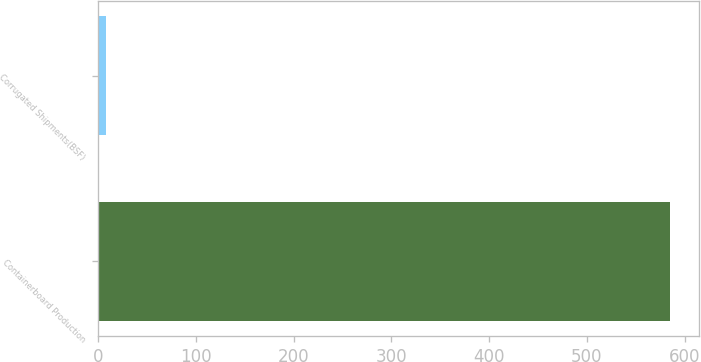<chart> <loc_0><loc_0><loc_500><loc_500><bar_chart><fcel>Containerboard Production<fcel>Corrugated Shipments(BSF)<nl><fcel>585<fcel>8<nl></chart> 